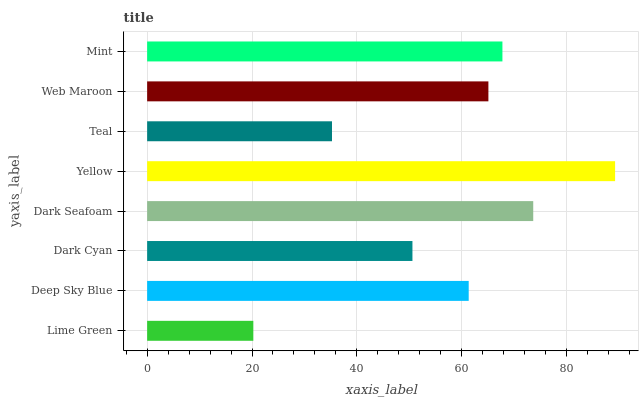Is Lime Green the minimum?
Answer yes or no. Yes. Is Yellow the maximum?
Answer yes or no. Yes. Is Deep Sky Blue the minimum?
Answer yes or no. No. Is Deep Sky Blue the maximum?
Answer yes or no. No. Is Deep Sky Blue greater than Lime Green?
Answer yes or no. Yes. Is Lime Green less than Deep Sky Blue?
Answer yes or no. Yes. Is Lime Green greater than Deep Sky Blue?
Answer yes or no. No. Is Deep Sky Blue less than Lime Green?
Answer yes or no. No. Is Web Maroon the high median?
Answer yes or no. Yes. Is Deep Sky Blue the low median?
Answer yes or no. Yes. Is Yellow the high median?
Answer yes or no. No. Is Mint the low median?
Answer yes or no. No. 